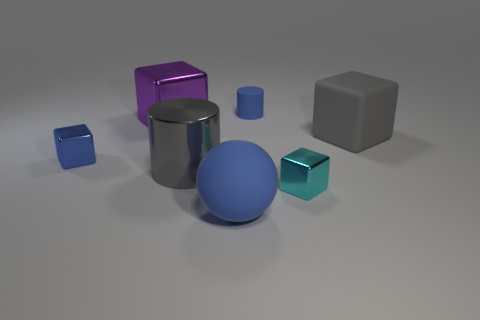Subtract 1 blocks. How many blocks are left? 3 Add 1 small yellow cubes. How many objects exist? 8 Subtract all spheres. How many objects are left? 6 Add 5 big gray shiny objects. How many big gray shiny objects are left? 6 Add 7 large gray matte things. How many large gray matte things exist? 8 Subtract 0 cyan cylinders. How many objects are left? 7 Subtract all large blue rubber cylinders. Subtract all blue spheres. How many objects are left? 6 